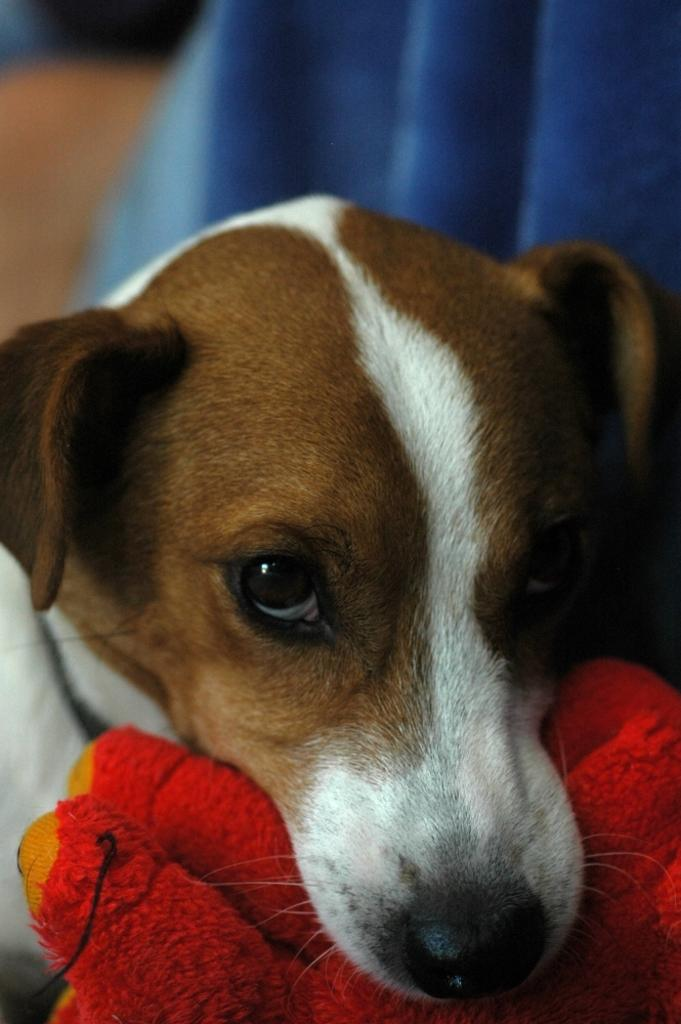What type of animal is in the picture? There is a dog in the picture. Can you describe the dog's appearance? The dog is white and brown in color. What other objects can be seen in the picture? There is a red color cloth in the picture. What color is the cloth visible in the background? There is a blue color cloth visible in the background of the picture. What organization does the dog represent in the picture? There is no indication in the image that the dog represents any organization. 